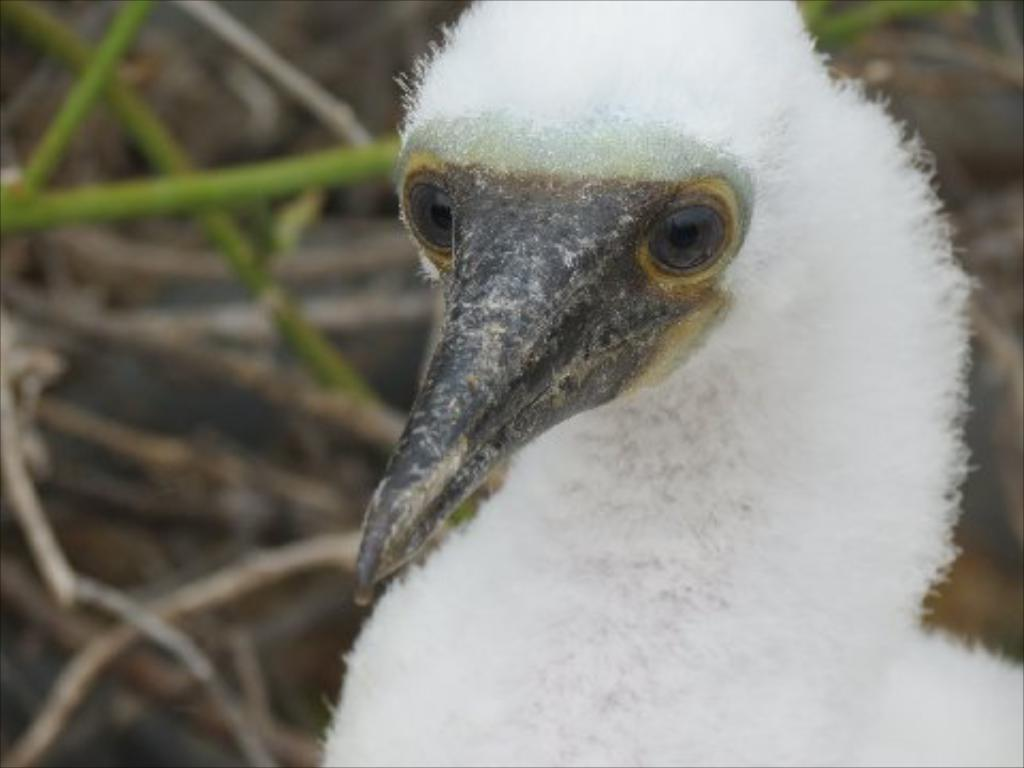What type of animal can be seen in the image? There is a bird in the image. What can be seen in the background of the image? There are twigs in the background of the image. How much oil is required for the bird to sleep comfortably in the image? There is no mention of oil or the bird sleeping in the image, so this question cannot be answered. 